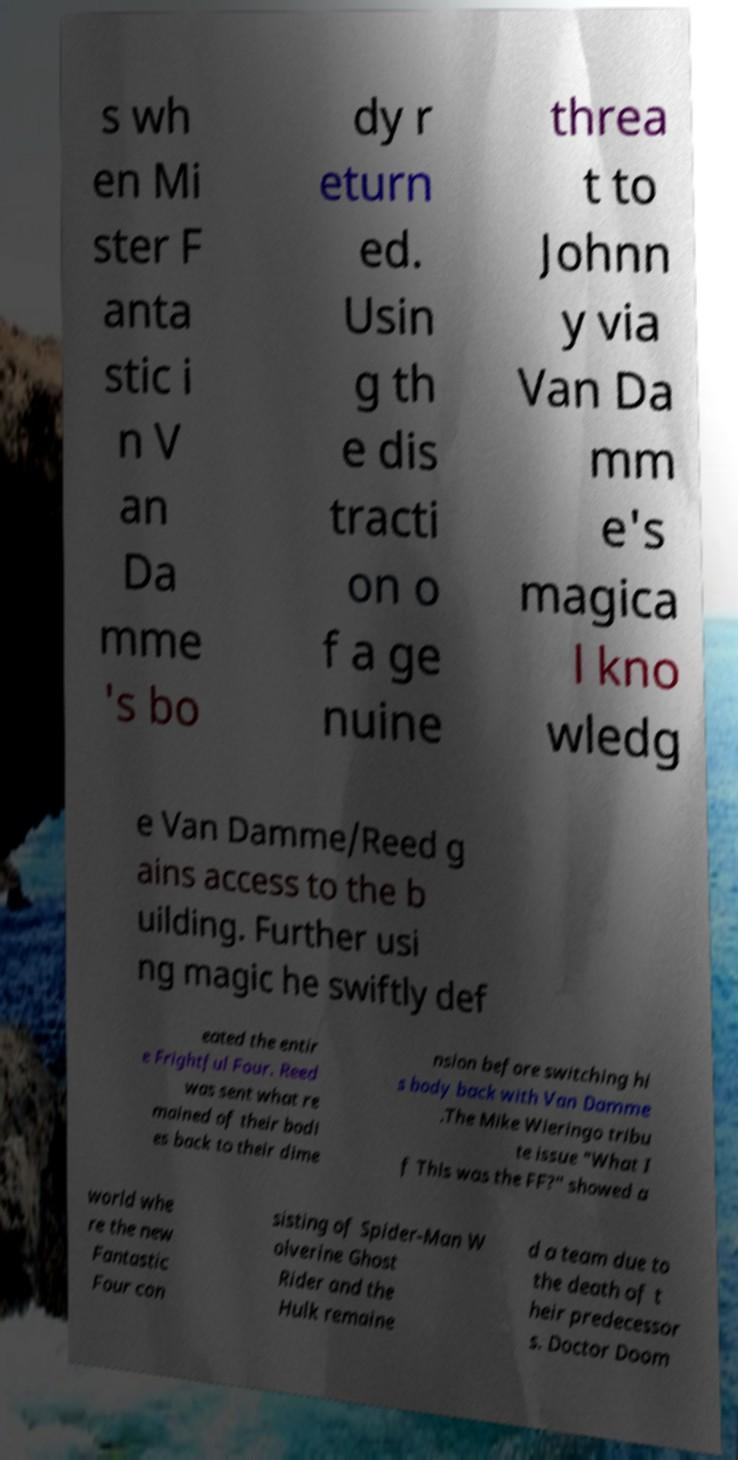Could you assist in decoding the text presented in this image and type it out clearly? s wh en Mi ster F anta stic i n V an Da mme 's bo dy r eturn ed. Usin g th e dis tracti on o f a ge nuine threa t to Johnn y via Van Da mm e's magica l kno wledg e Van Damme/Reed g ains access to the b uilding. Further usi ng magic he swiftly def eated the entir e Frightful Four. Reed was sent what re mained of their bodi es back to their dime nsion before switching hi s body back with Van Damme .The Mike Wieringo tribu te issue "What I f This was the FF?" showed a world whe re the new Fantastic Four con sisting of Spider-Man W olverine Ghost Rider and the Hulk remaine d a team due to the death of t heir predecessor s. Doctor Doom 